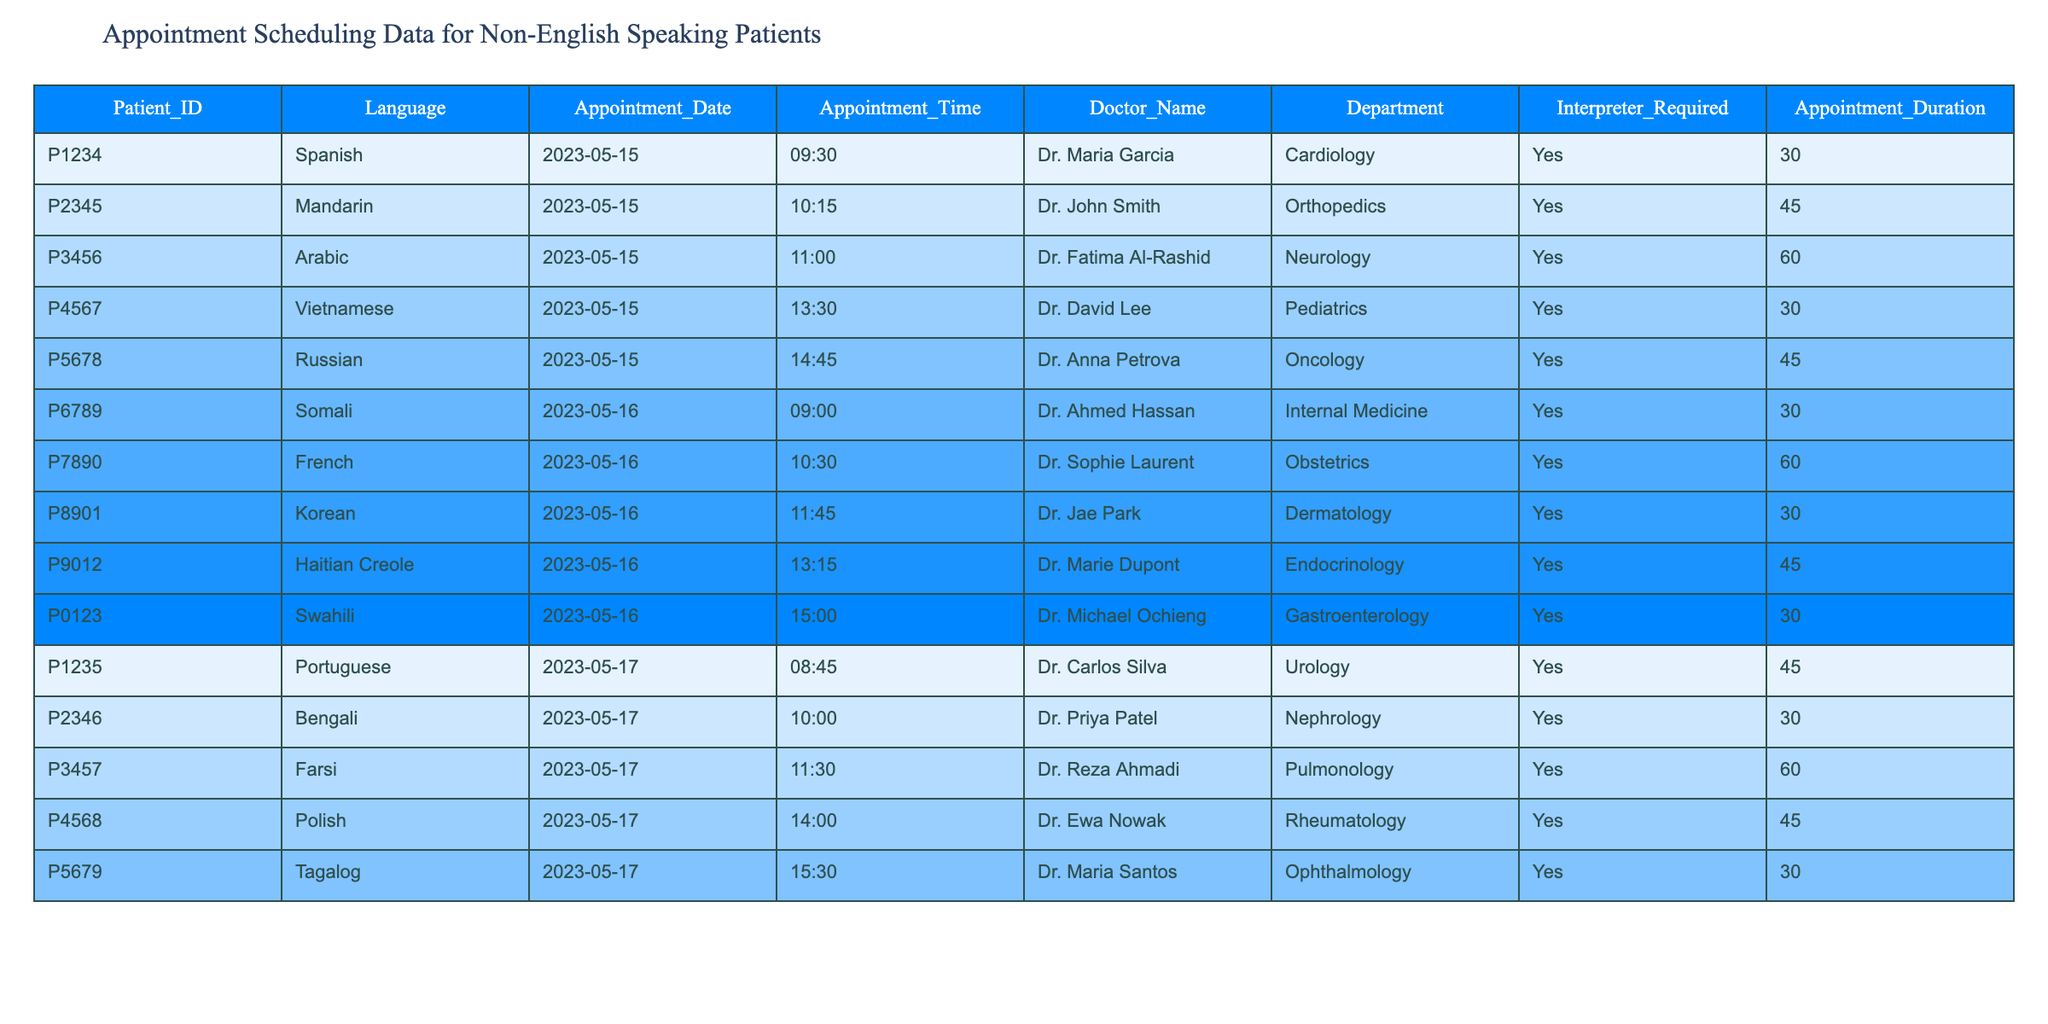What is the appointment date for patient P6789? Looking at the table, the row corresponding to patient ID P6789 shows that the appointment date is 2023-05-16.
Answer: 2023-05-16 Which department does Dr. Reza Ahmadi work in? Referring to the information about the doctor, Dr. Reza Ahmadi is listed under the Pulmonology department.
Answer: Pulmonology How many total appointments are scheduled on May 17, 2023? Counting the number of appointments listed for the date May 17, 2023, we see there are 5 appointments scheduled.
Answer: 5 What is the duration of the appointment for patient P9012? Checking the appointment details for patient ID P9012, the duration of the appointment is listed as 45 minutes.
Answer: 45 Which language is spoken by patient P2345? Referring to the table under the language column, patient ID P2345 speaks Mandarin.
Answer: Mandarin Is an interpreter required for all scheduled appointments? Looking across the table, every row indicates that an interpreter is required for all patients scheduled. Therefore, the answer is yes.
Answer: Yes What are the total appointment durations scheduled for all patients on May 16, 2023? Summing the appointment durations for May 16, we have 30 (Somali) + 60 (French) + 30 (Korean) + 45 (Haitian Creole) + 30 (Swahili) = 195 minutes total.
Answer: 195 How many different languages are represented on May 15, 2023? The data for May 15 shows 5 patients speaking different languages: Spanish, Mandarin, Arabic, Vietnamese, and Russian. Counting these gives us a total of 5 different languages.
Answer: 5 What is the average duration of appointments for non-English speaking patients across all listed dates? Calculating the average, we first sum all appointment durations: (30+45+60+30+45+30+60+30+45+30+45+30+60+45+30) = 675. Dividing by the total number of appointments (15) gives us an average duration of 45 minutes.
Answer: 45 Which doctor has the most appointments scheduled? By reviewing the table, each doctor has a single appointment scheduled. Thus, there is no doctor with more than one appointment, making it a tie among all.
Answer: None 